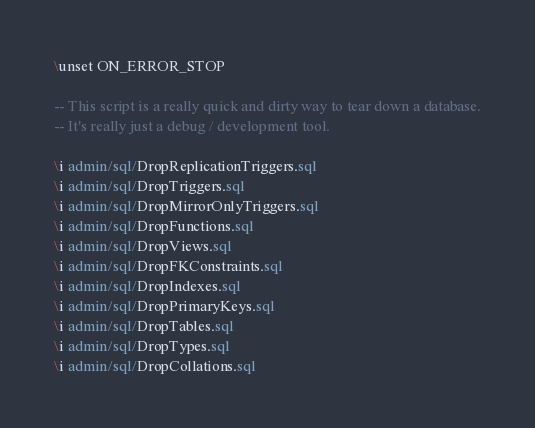<code> <loc_0><loc_0><loc_500><loc_500><_SQL_>\unset ON_ERROR_STOP

-- This script is a really quick and dirty way to tear down a database.
-- It's really just a debug / development tool.

\i admin/sql/DropReplicationTriggers.sql
\i admin/sql/DropTriggers.sql
\i admin/sql/DropMirrorOnlyTriggers.sql
\i admin/sql/DropFunctions.sql
\i admin/sql/DropViews.sql
\i admin/sql/DropFKConstraints.sql
\i admin/sql/DropIndexes.sql
\i admin/sql/DropPrimaryKeys.sql
\i admin/sql/DropTables.sql
\i admin/sql/DropTypes.sql
\i admin/sql/DropCollations.sql
</code> 